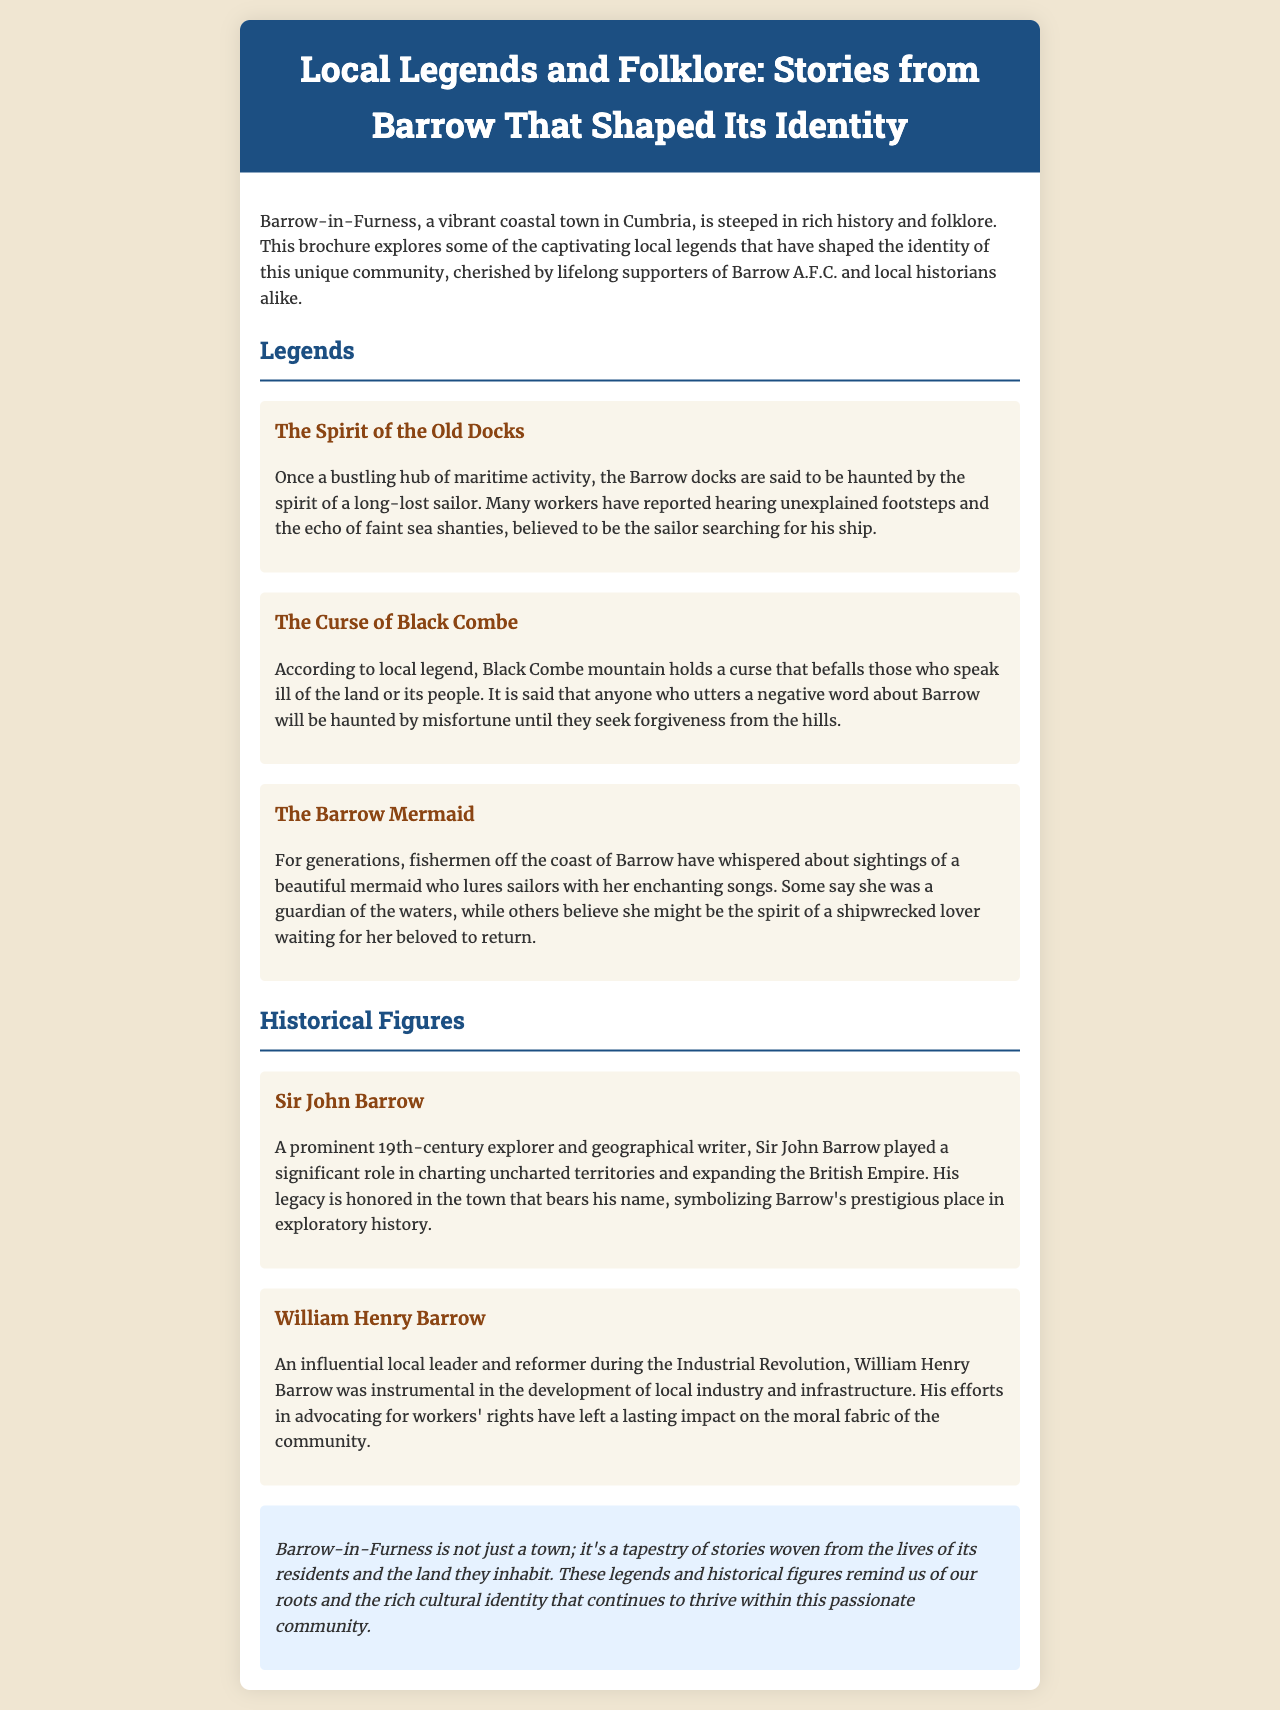What is the title of the brochure? The title of the brochure is prominently displayed at the top and describes its focus on local legends and folklore.
Answer: Local Legends and Folklore: Stories from Barrow That Shaped Its Identity Who is said to haunt the Barrow docks? The brochure mentions a specific figure that has been reported by workers in the dock area.
Answer: The spirit of a long-lost sailor What curse is associated with Black Combe? The brochure describes a specific consequence that befalls those who disrespect the land or its people.
Answer: The Curse of Black Combe Who was a prominent 19th-century explorer mentioned in the document? The document lists this historical figure, whose legacy is tied to exploration and is honored in Barrow.
Answer: Sir John Barrow What role did William Henry Barrow have during the Industrial Revolution? The brochure provides insight into this individual's contributions to local industry and infrastructure.
Answer: Local leader and reformer What type of content is this document? The overall context and aim of the document suggest what kind of informational content it provides.
Answer: Brochure What enchanting creature is discussed in Barrow's folklore? The document refers to a specific mythical being associated with the coastal area and local fishermen.
Answer: The Barrow Mermaid How does the brochure conclude about Barrow-in-Furness? The final statement reflects a sentiment about the town's identity and stories.
Answer: A tapestry of stories 